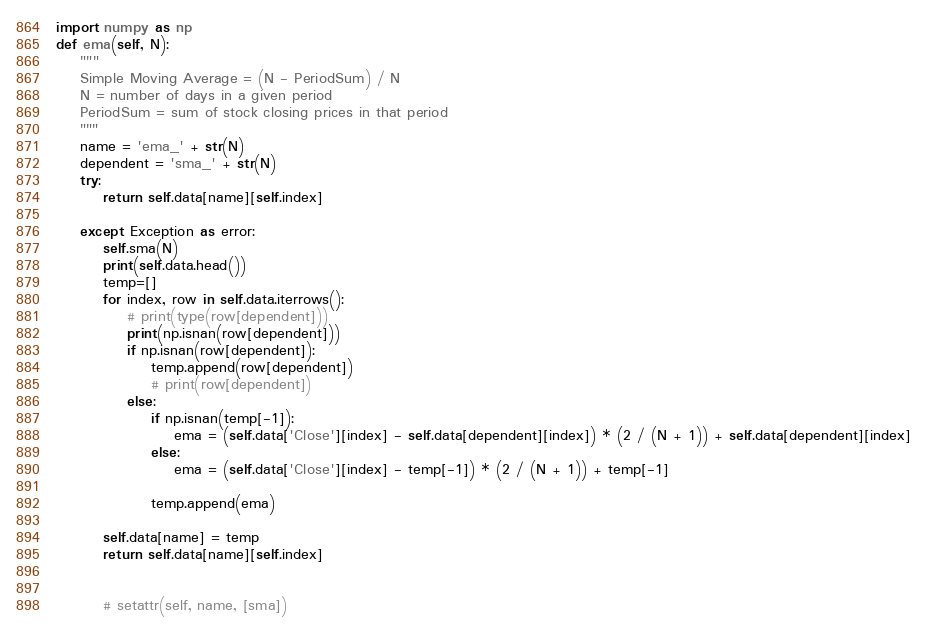Convert code to text. <code><loc_0><loc_0><loc_500><loc_500><_Python_>import numpy as np
def ema(self, N):
    """
    Simple Moving Average = (N - PeriodSum) / N
    N = number of days in a given period
    PeriodSum = sum of stock closing prices in that period
    """
    name = 'ema_' + str(N)
    dependent = 'sma_' + str(N)
    try:
        return self.data[name][self.index]
            
    except Exception as error:
        self.sma(N)
        print(self.data.head())
        temp=[]
        for index, row in self.data.iterrows():
            # print(type(row[dependent]))
            print(np.isnan(row[dependent]))
            if np.isnan(row[dependent]):
                temp.append(row[dependent])
                # print(row[dependent])
            else:
                if np.isnan(temp[-1]):
                    ema = (self.data['Close'][index] - self.data[dependent][index]) * (2 / (N + 1)) + self.data[dependent][index]
                else:
                    ema = (self.data['Close'][index] - temp[-1]) * (2 / (N + 1)) + temp[-1]
                
                temp.append(ema)
        
        self.data[name] = temp
        return self.data[name][self.index]
                
                
        # setattr(self, name, [sma])</code> 